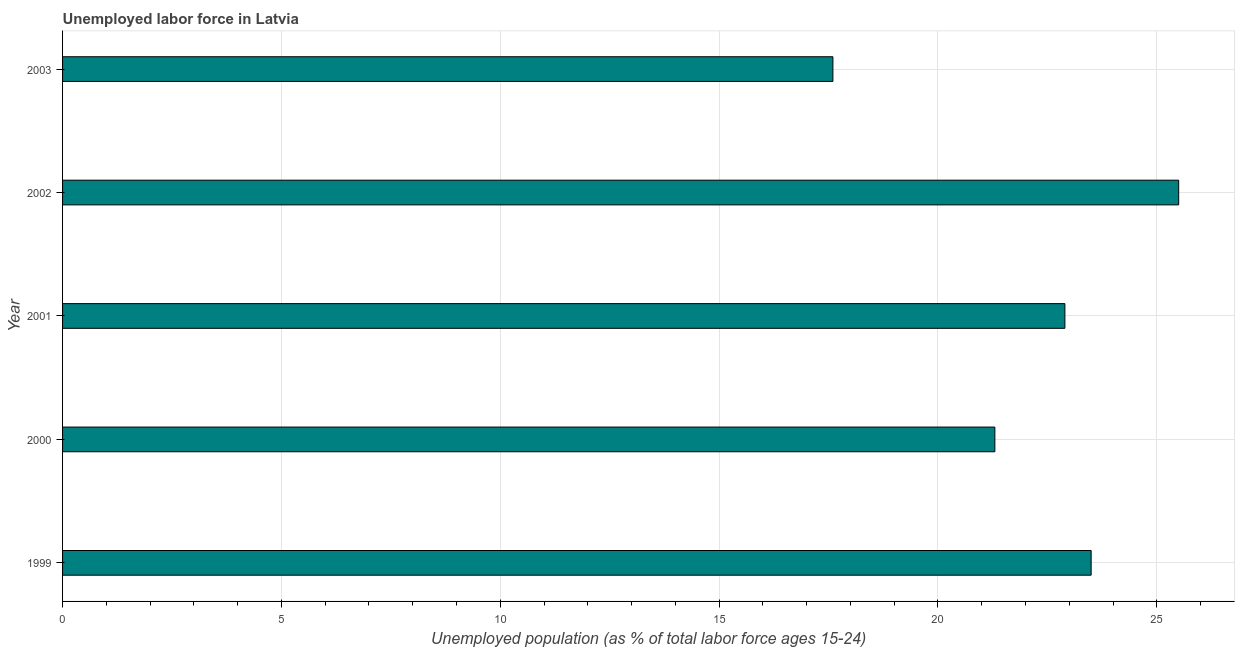What is the title of the graph?
Give a very brief answer. Unemployed labor force in Latvia. What is the label or title of the X-axis?
Make the answer very short. Unemployed population (as % of total labor force ages 15-24). Across all years, what is the maximum total unemployed youth population?
Your response must be concise. 25.5. Across all years, what is the minimum total unemployed youth population?
Your answer should be compact. 17.6. What is the sum of the total unemployed youth population?
Offer a very short reply. 110.8. What is the average total unemployed youth population per year?
Ensure brevity in your answer.  22.16. What is the median total unemployed youth population?
Give a very brief answer. 22.9. Do a majority of the years between 2002 and 2003 (inclusive) have total unemployed youth population greater than 1 %?
Offer a very short reply. Yes. What is the ratio of the total unemployed youth population in 1999 to that in 2000?
Ensure brevity in your answer.  1.1. Is the total unemployed youth population in 1999 less than that in 2003?
Ensure brevity in your answer.  No. Is the difference between the total unemployed youth population in 2001 and 2003 greater than the difference between any two years?
Give a very brief answer. No. In how many years, is the total unemployed youth population greater than the average total unemployed youth population taken over all years?
Give a very brief answer. 3. Are all the bars in the graph horizontal?
Make the answer very short. Yes. How many years are there in the graph?
Provide a succinct answer. 5. What is the Unemployed population (as % of total labor force ages 15-24) of 2000?
Give a very brief answer. 21.3. What is the Unemployed population (as % of total labor force ages 15-24) in 2001?
Your answer should be very brief. 22.9. What is the Unemployed population (as % of total labor force ages 15-24) in 2002?
Provide a succinct answer. 25.5. What is the Unemployed population (as % of total labor force ages 15-24) of 2003?
Ensure brevity in your answer.  17.6. What is the difference between the Unemployed population (as % of total labor force ages 15-24) in 1999 and 2002?
Offer a very short reply. -2. What is the difference between the Unemployed population (as % of total labor force ages 15-24) in 2001 and 2002?
Make the answer very short. -2.6. What is the difference between the Unemployed population (as % of total labor force ages 15-24) in 2001 and 2003?
Offer a very short reply. 5.3. What is the difference between the Unemployed population (as % of total labor force ages 15-24) in 2002 and 2003?
Ensure brevity in your answer.  7.9. What is the ratio of the Unemployed population (as % of total labor force ages 15-24) in 1999 to that in 2000?
Offer a terse response. 1.1. What is the ratio of the Unemployed population (as % of total labor force ages 15-24) in 1999 to that in 2001?
Your answer should be compact. 1.03. What is the ratio of the Unemployed population (as % of total labor force ages 15-24) in 1999 to that in 2002?
Provide a succinct answer. 0.92. What is the ratio of the Unemployed population (as % of total labor force ages 15-24) in 1999 to that in 2003?
Provide a short and direct response. 1.33. What is the ratio of the Unemployed population (as % of total labor force ages 15-24) in 2000 to that in 2001?
Keep it short and to the point. 0.93. What is the ratio of the Unemployed population (as % of total labor force ages 15-24) in 2000 to that in 2002?
Your answer should be very brief. 0.83. What is the ratio of the Unemployed population (as % of total labor force ages 15-24) in 2000 to that in 2003?
Your answer should be very brief. 1.21. What is the ratio of the Unemployed population (as % of total labor force ages 15-24) in 2001 to that in 2002?
Your answer should be compact. 0.9. What is the ratio of the Unemployed population (as % of total labor force ages 15-24) in 2001 to that in 2003?
Offer a very short reply. 1.3. What is the ratio of the Unemployed population (as % of total labor force ages 15-24) in 2002 to that in 2003?
Make the answer very short. 1.45. 